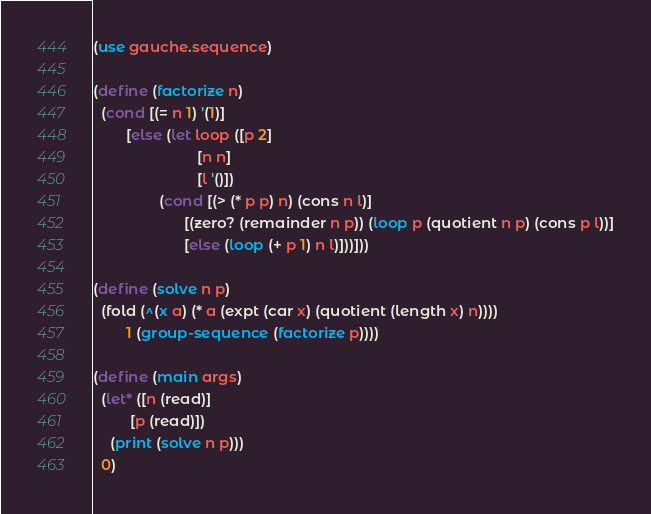Convert code to text. <code><loc_0><loc_0><loc_500><loc_500><_Scheme_>(use gauche.sequence)

(define (factorize n)
  (cond [(= n 1) '(1)]
        [else (let loop ([p 2]
                         [n n]
                         [l '()])
                (cond [(> (* p p) n) (cons n l)]
                      [(zero? (remainder n p)) (loop p (quotient n p) (cons p l))]
                      [else (loop (+ p 1) n l)]))]))

(define (solve n p)
  (fold (^(x a) (* a (expt (car x) (quotient (length x) n))))
        1 (group-sequence (factorize p))))

(define (main args)
  (let* ([n (read)]
         [p (read)])
    (print (solve n p)))
  0)
</code> 